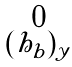<formula> <loc_0><loc_0><loc_500><loc_500>\begin{smallmatrix} 0 \\ ( h _ { b } ) _ { y } \end{smallmatrix}</formula> 